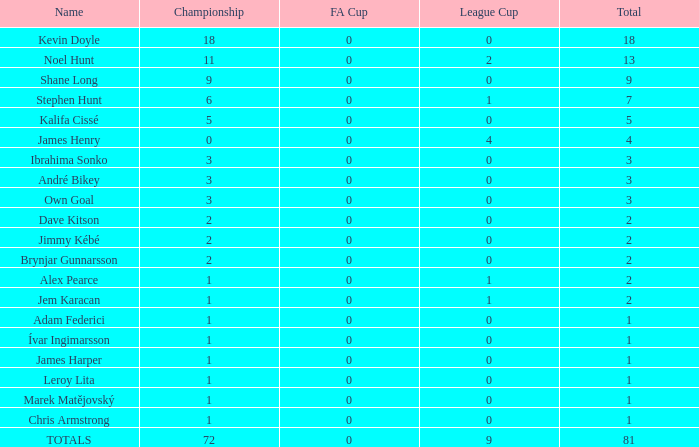What is the total number of championships in the league cup that is less than 0? None. 